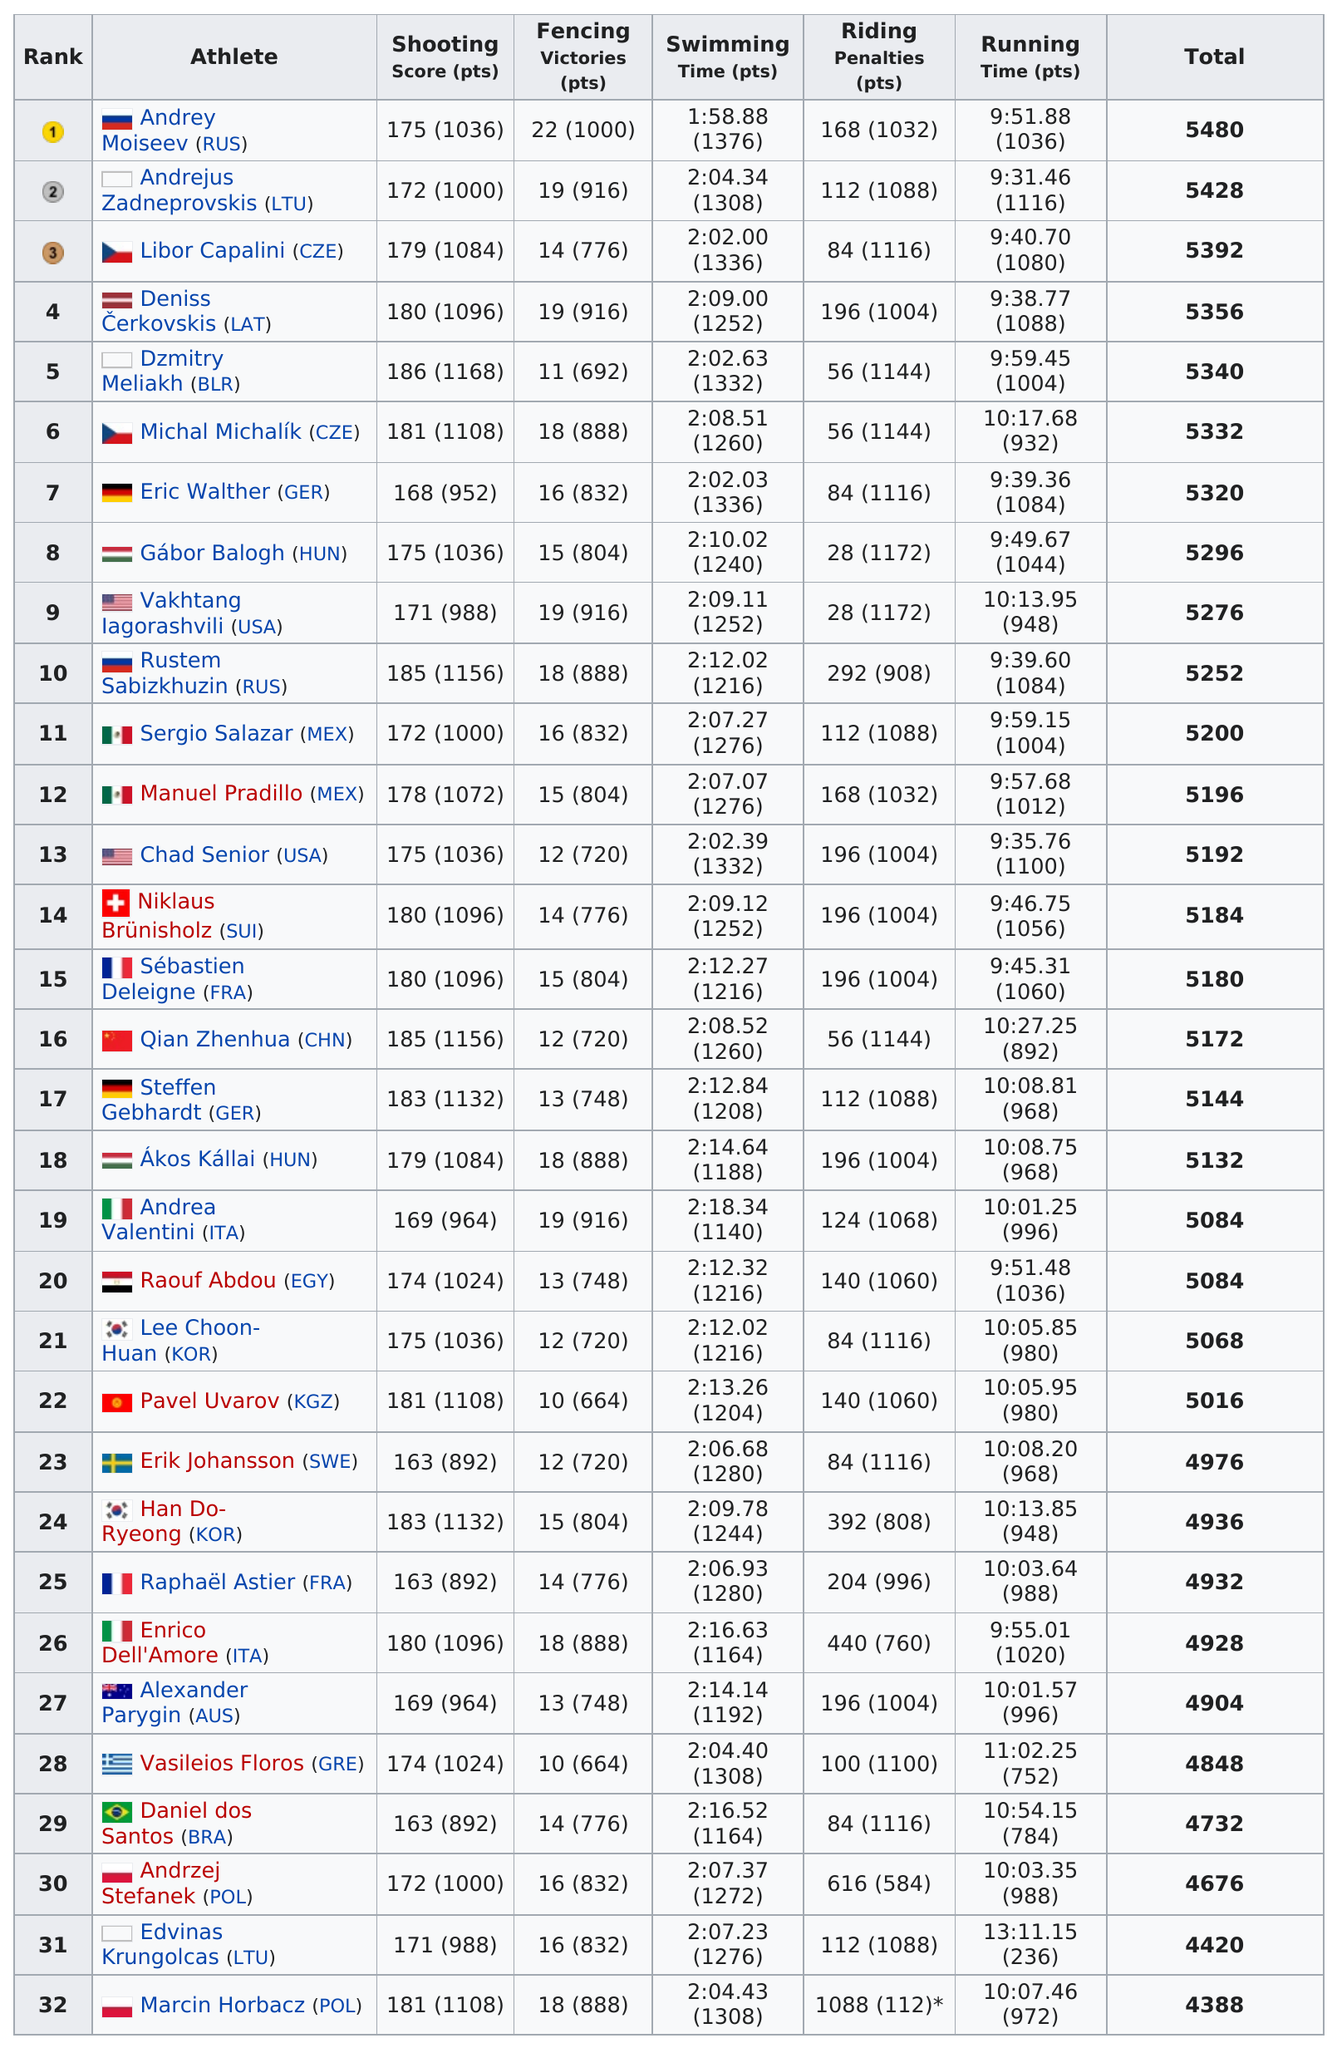Indicate a few pertinent items in this graphic. The difference between Andrey Moiseev's total score and Marcin Horbacz's total score is 1092. Poland had the competitor with the least amount of points, making it the country with the least amount of points in the competition. Eric Walther had the most points in running, as compared to Sergio Salazar. In total, 22 athletes scored more than 5000 points. In the riding competition, a total of 11 athletes earned more than 1,100 points. 